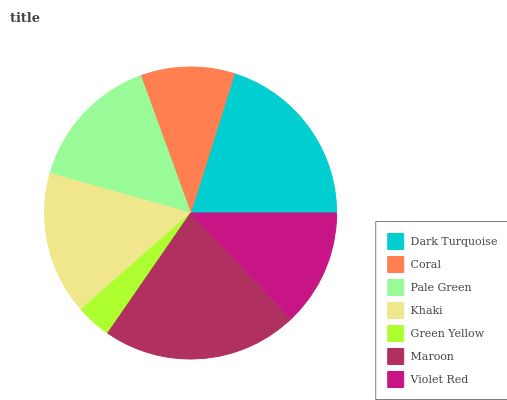Is Green Yellow the minimum?
Answer yes or no. Yes. Is Maroon the maximum?
Answer yes or no. Yes. Is Coral the minimum?
Answer yes or no. No. Is Coral the maximum?
Answer yes or no. No. Is Dark Turquoise greater than Coral?
Answer yes or no. Yes. Is Coral less than Dark Turquoise?
Answer yes or no. Yes. Is Coral greater than Dark Turquoise?
Answer yes or no. No. Is Dark Turquoise less than Coral?
Answer yes or no. No. Is Pale Green the high median?
Answer yes or no. Yes. Is Pale Green the low median?
Answer yes or no. Yes. Is Green Yellow the high median?
Answer yes or no. No. Is Green Yellow the low median?
Answer yes or no. No. 